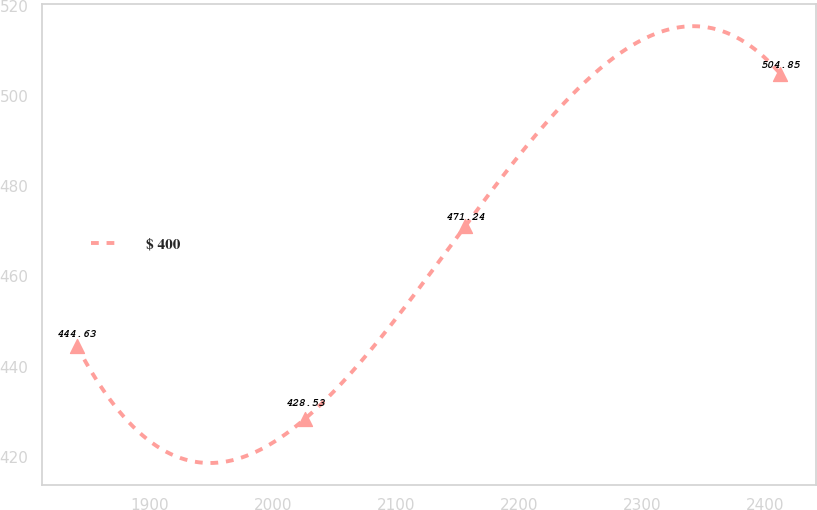Convert chart. <chart><loc_0><loc_0><loc_500><loc_500><line_chart><ecel><fcel>$ 400<nl><fcel>1840.6<fcel>444.63<nl><fcel>2026.33<fcel>428.53<nl><fcel>2156.43<fcel>471.24<nl><fcel>2412.41<fcel>504.85<nl></chart> 